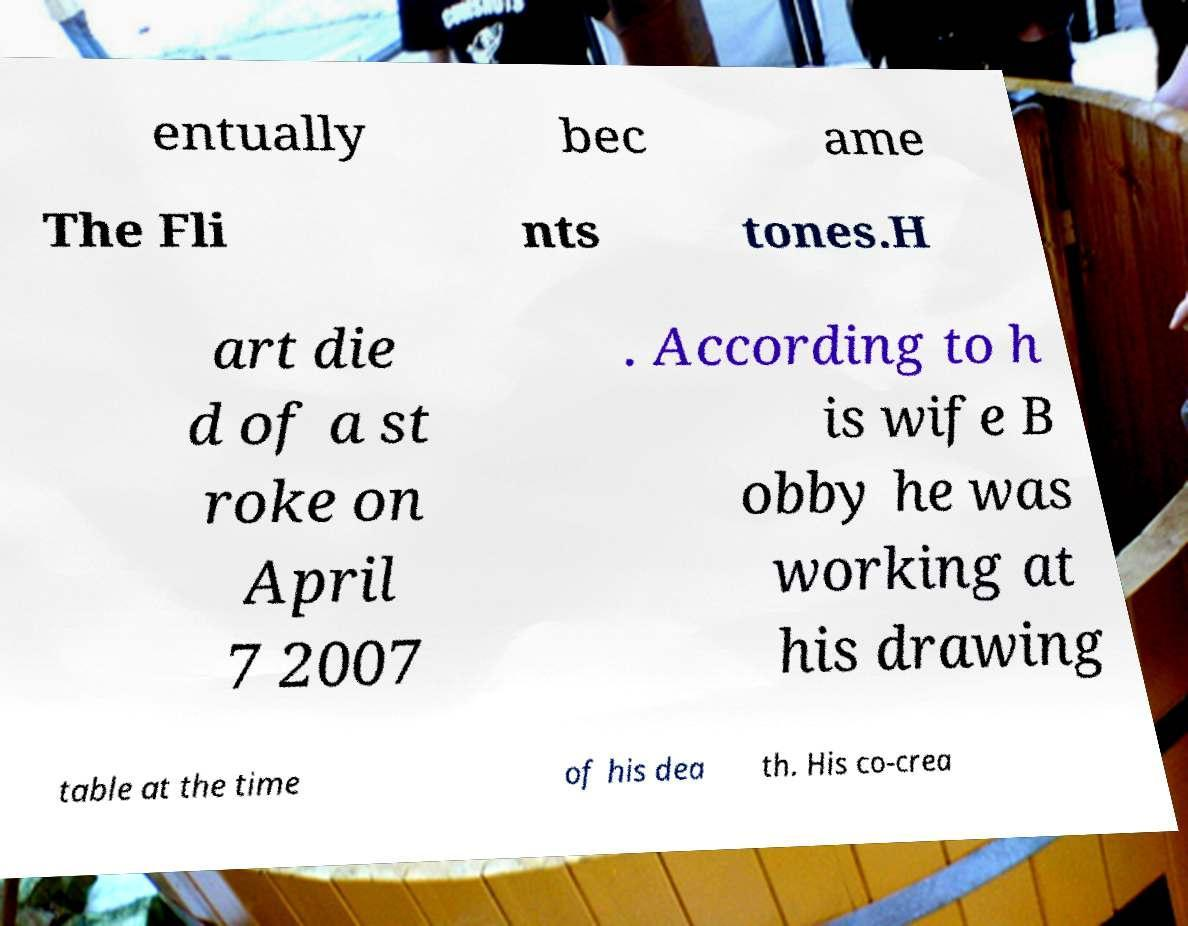Please read and relay the text visible in this image. What does it say? entually bec ame The Fli nts tones.H art die d of a st roke on April 7 2007 . According to h is wife B obby he was working at his drawing table at the time of his dea th. His co-crea 